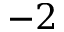Convert formula to latex. <formula><loc_0><loc_0><loc_500><loc_500>{ - 2 }</formula> 